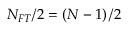Convert formula to latex. <formula><loc_0><loc_0><loc_500><loc_500>N _ { F T } / 2 = \left ( N - 1 \right ) / 2</formula> 